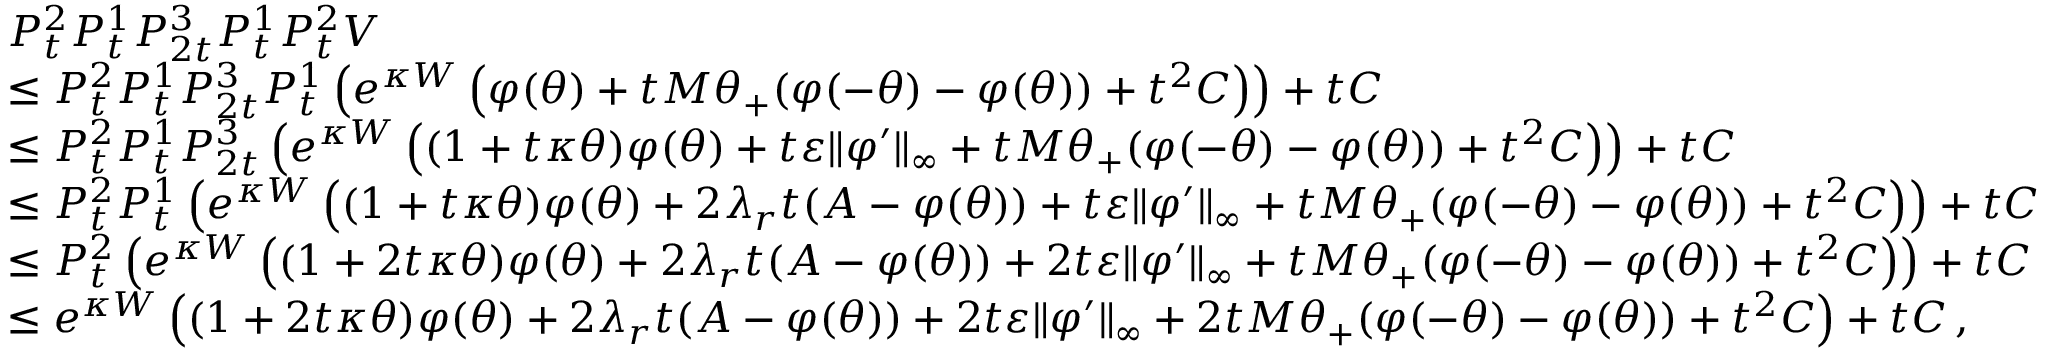Convert formula to latex. <formula><loc_0><loc_0><loc_500><loc_500>\begin{array} { r l } & { { P _ { t } ^ { 2 } P _ { t } ^ { 1 } P _ { 2 t } ^ { 3 } P _ { t } ^ { 1 } P _ { t } ^ { 2 } V } } \\ & { \leq P _ { t } ^ { 2 } P _ { t } ^ { 1 } P _ { 2 t } ^ { 3 } P _ { t } ^ { 1 } \left ( e ^ { \kappa W } \left ( \varphi ( \theta ) + t M \theta _ { + } ( \varphi ( - \theta ) - \varphi ( \theta ) ) + t ^ { 2 } C \right ) \right ) + t C } \\ & { \leq P _ { t } ^ { 2 } P _ { t } ^ { 1 } P _ { 2 t } ^ { 3 } \left ( e ^ { \kappa W } \left ( ( 1 + t \kappa \theta ) \varphi ( \theta ) + t \varepsilon \| \varphi ^ { \prime } \| _ { \infty } + t M \theta _ { + } ( \varphi ( - \theta ) - \varphi ( \theta ) ) + t ^ { 2 } C \right ) \right ) + t C } \\ & { \leq P _ { t } ^ { 2 } P _ { t } ^ { 1 } \left ( e ^ { \kappa W } \left ( ( 1 + t \kappa \theta ) \varphi ( \theta ) + 2 \lambda _ { r } t ( A - \varphi ( \theta ) ) + t \varepsilon \| \varphi ^ { \prime } \| _ { \infty } + t M \theta _ { + } ( \varphi ( - \theta ) - \varphi ( \theta ) ) + t ^ { 2 } C \right ) \right ) + t C } \\ & { \leq P _ { t } ^ { 2 } \left ( e ^ { \kappa W } \left ( ( 1 + 2 t \kappa \theta ) \varphi ( \theta ) + 2 \lambda _ { r } t ( A - \varphi ( \theta ) ) + 2 t \varepsilon \| \varphi ^ { \prime } \| _ { \infty } + t M \theta _ { + } ( \varphi ( - \theta ) - \varphi ( \theta ) ) + t ^ { 2 } C \right ) \right ) + t C } \\ & { \leq e ^ { \kappa W } \left ( ( 1 + 2 t \kappa \theta ) \varphi ( \theta ) + 2 \lambda _ { r } t ( A - \varphi ( \theta ) ) + 2 t \varepsilon \| \varphi ^ { \prime } \| _ { \infty } + 2 t M \theta _ { + } ( \varphi ( - \theta ) - \varphi ( \theta ) ) + t ^ { 2 } C \right ) + t C \, , } \end{array}</formula> 